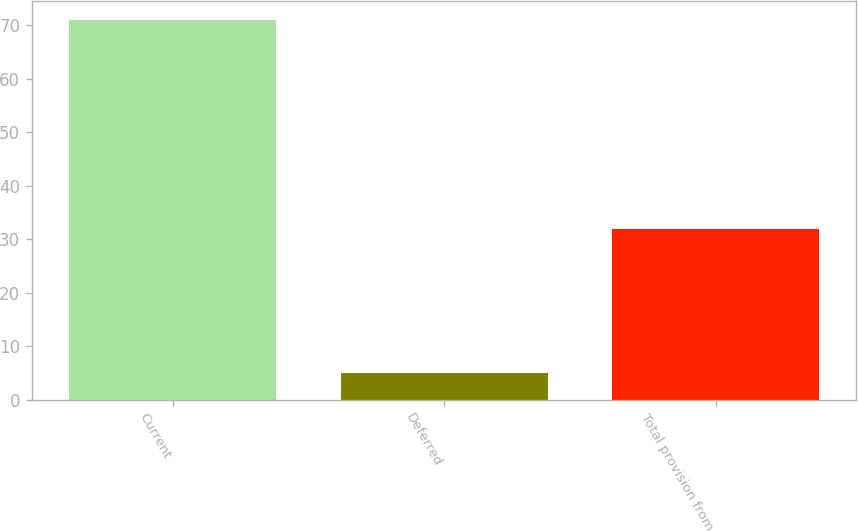<chart> <loc_0><loc_0><loc_500><loc_500><bar_chart><fcel>Current<fcel>Deferred<fcel>Total provision from<nl><fcel>71<fcel>5<fcel>32<nl></chart> 